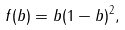Convert formula to latex. <formula><loc_0><loc_0><loc_500><loc_500>f ( b ) = b ( 1 - b ) ^ { 2 } ,</formula> 